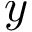<formula> <loc_0><loc_0><loc_500><loc_500>y</formula> 